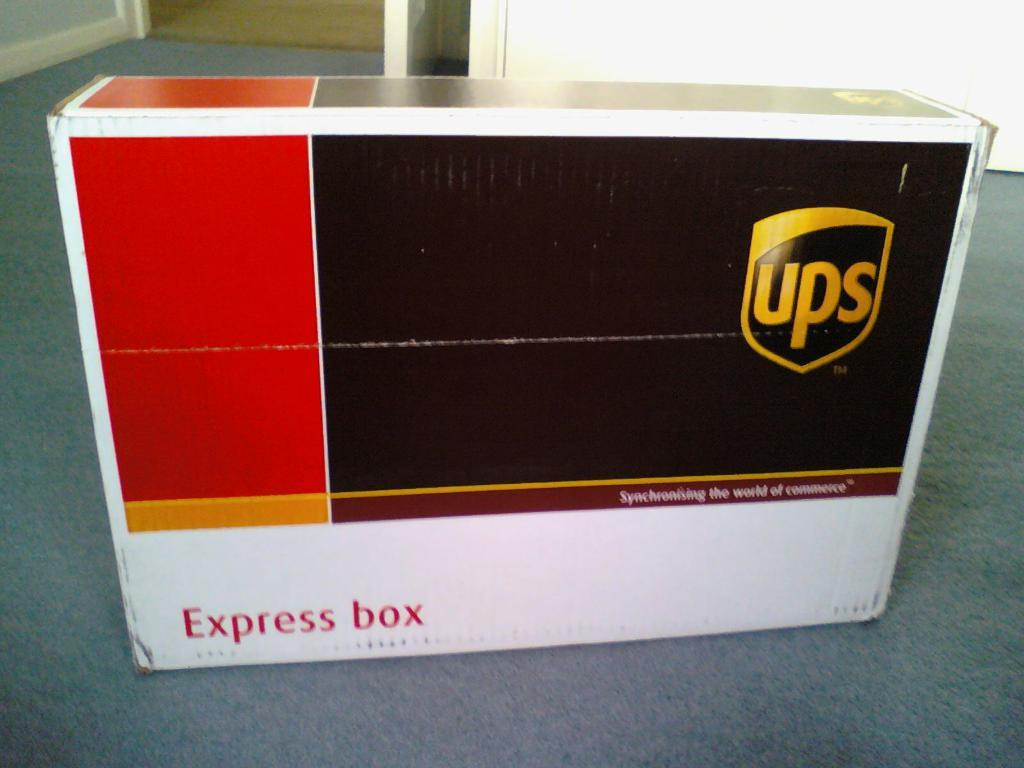Provide a one-sentence caption for the provided image. A UPS express box lays on the floor. 